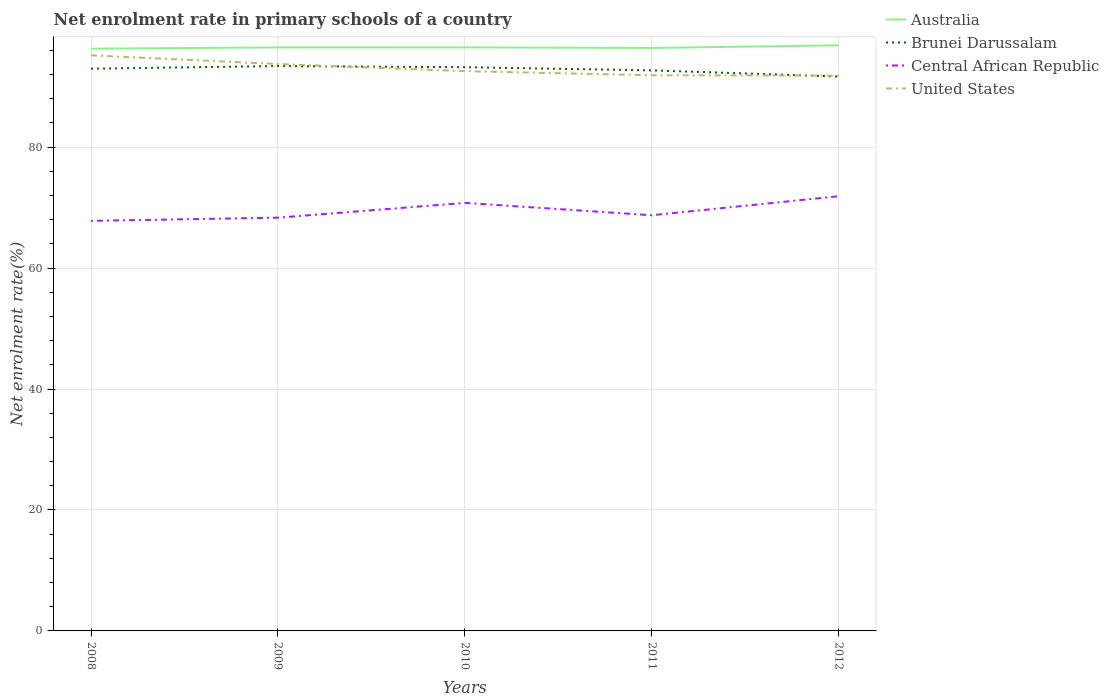How many different coloured lines are there?
Keep it short and to the point. 4. Is the number of lines equal to the number of legend labels?
Your answer should be compact. Yes. Across all years, what is the maximum net enrolment rate in primary schools in Central African Republic?
Keep it short and to the point. 67.8. What is the total net enrolment rate in primary schools in Central African Republic in the graph?
Offer a terse response. 2.05. What is the difference between the highest and the second highest net enrolment rate in primary schools in Australia?
Keep it short and to the point. 0.55. How many lines are there?
Make the answer very short. 4. What is the difference between two consecutive major ticks on the Y-axis?
Keep it short and to the point. 20. Does the graph contain grids?
Offer a very short reply. Yes. Where does the legend appear in the graph?
Your answer should be very brief. Top right. How are the legend labels stacked?
Provide a short and direct response. Vertical. What is the title of the graph?
Ensure brevity in your answer.  Net enrolment rate in primary schools of a country. Does "Low income" appear as one of the legend labels in the graph?
Keep it short and to the point. No. What is the label or title of the X-axis?
Keep it short and to the point. Years. What is the label or title of the Y-axis?
Provide a short and direct response. Net enrolment rate(%). What is the Net enrolment rate(%) in Australia in 2008?
Give a very brief answer. 96.27. What is the Net enrolment rate(%) of Brunei Darussalam in 2008?
Ensure brevity in your answer.  92.97. What is the Net enrolment rate(%) in Central African Republic in 2008?
Provide a succinct answer. 67.8. What is the Net enrolment rate(%) in United States in 2008?
Keep it short and to the point. 95.17. What is the Net enrolment rate(%) of Australia in 2009?
Make the answer very short. 96.49. What is the Net enrolment rate(%) of Brunei Darussalam in 2009?
Ensure brevity in your answer.  93.4. What is the Net enrolment rate(%) in Central African Republic in 2009?
Provide a short and direct response. 68.33. What is the Net enrolment rate(%) in United States in 2009?
Ensure brevity in your answer.  93.73. What is the Net enrolment rate(%) in Australia in 2010?
Your response must be concise. 96.49. What is the Net enrolment rate(%) in Brunei Darussalam in 2010?
Your answer should be compact. 93.21. What is the Net enrolment rate(%) of Central African Republic in 2010?
Your answer should be compact. 70.77. What is the Net enrolment rate(%) in United States in 2010?
Provide a short and direct response. 92.56. What is the Net enrolment rate(%) in Australia in 2011?
Give a very brief answer. 96.4. What is the Net enrolment rate(%) of Brunei Darussalam in 2011?
Provide a succinct answer. 92.69. What is the Net enrolment rate(%) in Central African Republic in 2011?
Offer a terse response. 68.73. What is the Net enrolment rate(%) of United States in 2011?
Provide a short and direct response. 91.88. What is the Net enrolment rate(%) of Australia in 2012?
Keep it short and to the point. 96.82. What is the Net enrolment rate(%) of Brunei Darussalam in 2012?
Your answer should be very brief. 91.66. What is the Net enrolment rate(%) of Central African Republic in 2012?
Ensure brevity in your answer.  71.88. What is the Net enrolment rate(%) of United States in 2012?
Keep it short and to the point. 91.82. Across all years, what is the maximum Net enrolment rate(%) in Australia?
Give a very brief answer. 96.82. Across all years, what is the maximum Net enrolment rate(%) of Brunei Darussalam?
Provide a short and direct response. 93.4. Across all years, what is the maximum Net enrolment rate(%) in Central African Republic?
Your response must be concise. 71.88. Across all years, what is the maximum Net enrolment rate(%) of United States?
Your response must be concise. 95.17. Across all years, what is the minimum Net enrolment rate(%) in Australia?
Keep it short and to the point. 96.27. Across all years, what is the minimum Net enrolment rate(%) in Brunei Darussalam?
Your answer should be very brief. 91.66. Across all years, what is the minimum Net enrolment rate(%) in Central African Republic?
Your answer should be very brief. 67.8. Across all years, what is the minimum Net enrolment rate(%) of United States?
Ensure brevity in your answer.  91.82. What is the total Net enrolment rate(%) of Australia in the graph?
Your answer should be compact. 482.46. What is the total Net enrolment rate(%) of Brunei Darussalam in the graph?
Make the answer very short. 463.92. What is the total Net enrolment rate(%) in Central African Republic in the graph?
Ensure brevity in your answer.  347.51. What is the total Net enrolment rate(%) in United States in the graph?
Provide a short and direct response. 465.16. What is the difference between the Net enrolment rate(%) of Australia in 2008 and that in 2009?
Your answer should be very brief. -0.21. What is the difference between the Net enrolment rate(%) in Brunei Darussalam in 2008 and that in 2009?
Your answer should be very brief. -0.43. What is the difference between the Net enrolment rate(%) of Central African Republic in 2008 and that in 2009?
Offer a very short reply. -0.53. What is the difference between the Net enrolment rate(%) in United States in 2008 and that in 2009?
Provide a short and direct response. 1.44. What is the difference between the Net enrolment rate(%) of Australia in 2008 and that in 2010?
Give a very brief answer. -0.22. What is the difference between the Net enrolment rate(%) in Brunei Darussalam in 2008 and that in 2010?
Provide a short and direct response. -0.24. What is the difference between the Net enrolment rate(%) of Central African Republic in 2008 and that in 2010?
Keep it short and to the point. -2.97. What is the difference between the Net enrolment rate(%) in United States in 2008 and that in 2010?
Give a very brief answer. 2.61. What is the difference between the Net enrolment rate(%) in Australia in 2008 and that in 2011?
Provide a short and direct response. -0.12. What is the difference between the Net enrolment rate(%) in Brunei Darussalam in 2008 and that in 2011?
Your response must be concise. 0.28. What is the difference between the Net enrolment rate(%) of Central African Republic in 2008 and that in 2011?
Offer a terse response. -0.93. What is the difference between the Net enrolment rate(%) in United States in 2008 and that in 2011?
Your response must be concise. 3.3. What is the difference between the Net enrolment rate(%) of Australia in 2008 and that in 2012?
Ensure brevity in your answer.  -0.55. What is the difference between the Net enrolment rate(%) of Brunei Darussalam in 2008 and that in 2012?
Provide a short and direct response. 1.31. What is the difference between the Net enrolment rate(%) of Central African Republic in 2008 and that in 2012?
Give a very brief answer. -4.07. What is the difference between the Net enrolment rate(%) of United States in 2008 and that in 2012?
Give a very brief answer. 3.35. What is the difference between the Net enrolment rate(%) of Australia in 2009 and that in 2010?
Your answer should be compact. -0.01. What is the difference between the Net enrolment rate(%) in Brunei Darussalam in 2009 and that in 2010?
Your response must be concise. 0.19. What is the difference between the Net enrolment rate(%) of Central African Republic in 2009 and that in 2010?
Your response must be concise. -2.45. What is the difference between the Net enrolment rate(%) in United States in 2009 and that in 2010?
Provide a short and direct response. 1.17. What is the difference between the Net enrolment rate(%) of Australia in 2009 and that in 2011?
Your response must be concise. 0.09. What is the difference between the Net enrolment rate(%) in Brunei Darussalam in 2009 and that in 2011?
Make the answer very short. 0.71. What is the difference between the Net enrolment rate(%) of Central African Republic in 2009 and that in 2011?
Your answer should be very brief. -0.4. What is the difference between the Net enrolment rate(%) of United States in 2009 and that in 2011?
Give a very brief answer. 1.86. What is the difference between the Net enrolment rate(%) of Australia in 2009 and that in 2012?
Offer a very short reply. -0.34. What is the difference between the Net enrolment rate(%) of Brunei Darussalam in 2009 and that in 2012?
Make the answer very short. 1.74. What is the difference between the Net enrolment rate(%) in Central African Republic in 2009 and that in 2012?
Give a very brief answer. -3.55. What is the difference between the Net enrolment rate(%) in United States in 2009 and that in 2012?
Keep it short and to the point. 1.91. What is the difference between the Net enrolment rate(%) in Australia in 2010 and that in 2011?
Ensure brevity in your answer.  0.1. What is the difference between the Net enrolment rate(%) of Brunei Darussalam in 2010 and that in 2011?
Offer a terse response. 0.52. What is the difference between the Net enrolment rate(%) in Central African Republic in 2010 and that in 2011?
Ensure brevity in your answer.  2.05. What is the difference between the Net enrolment rate(%) in United States in 2010 and that in 2011?
Offer a terse response. 0.68. What is the difference between the Net enrolment rate(%) of Australia in 2010 and that in 2012?
Keep it short and to the point. -0.33. What is the difference between the Net enrolment rate(%) of Brunei Darussalam in 2010 and that in 2012?
Offer a very short reply. 1.55. What is the difference between the Net enrolment rate(%) of Central African Republic in 2010 and that in 2012?
Your answer should be very brief. -1.1. What is the difference between the Net enrolment rate(%) in United States in 2010 and that in 2012?
Give a very brief answer. 0.73. What is the difference between the Net enrolment rate(%) in Australia in 2011 and that in 2012?
Offer a very short reply. -0.43. What is the difference between the Net enrolment rate(%) of Brunei Darussalam in 2011 and that in 2012?
Offer a terse response. 1.03. What is the difference between the Net enrolment rate(%) in Central African Republic in 2011 and that in 2012?
Ensure brevity in your answer.  -3.15. What is the difference between the Net enrolment rate(%) of United States in 2011 and that in 2012?
Your response must be concise. 0.05. What is the difference between the Net enrolment rate(%) in Australia in 2008 and the Net enrolment rate(%) in Brunei Darussalam in 2009?
Your answer should be very brief. 2.87. What is the difference between the Net enrolment rate(%) of Australia in 2008 and the Net enrolment rate(%) of Central African Republic in 2009?
Offer a terse response. 27.94. What is the difference between the Net enrolment rate(%) of Australia in 2008 and the Net enrolment rate(%) of United States in 2009?
Keep it short and to the point. 2.54. What is the difference between the Net enrolment rate(%) of Brunei Darussalam in 2008 and the Net enrolment rate(%) of Central African Republic in 2009?
Ensure brevity in your answer.  24.64. What is the difference between the Net enrolment rate(%) in Brunei Darussalam in 2008 and the Net enrolment rate(%) in United States in 2009?
Ensure brevity in your answer.  -0.77. What is the difference between the Net enrolment rate(%) in Central African Republic in 2008 and the Net enrolment rate(%) in United States in 2009?
Make the answer very short. -25.93. What is the difference between the Net enrolment rate(%) in Australia in 2008 and the Net enrolment rate(%) in Brunei Darussalam in 2010?
Ensure brevity in your answer.  3.06. What is the difference between the Net enrolment rate(%) of Australia in 2008 and the Net enrolment rate(%) of Central African Republic in 2010?
Keep it short and to the point. 25.5. What is the difference between the Net enrolment rate(%) in Australia in 2008 and the Net enrolment rate(%) in United States in 2010?
Make the answer very short. 3.71. What is the difference between the Net enrolment rate(%) in Brunei Darussalam in 2008 and the Net enrolment rate(%) in Central African Republic in 2010?
Make the answer very short. 22.19. What is the difference between the Net enrolment rate(%) in Brunei Darussalam in 2008 and the Net enrolment rate(%) in United States in 2010?
Offer a terse response. 0.41. What is the difference between the Net enrolment rate(%) of Central African Republic in 2008 and the Net enrolment rate(%) of United States in 2010?
Provide a short and direct response. -24.76. What is the difference between the Net enrolment rate(%) of Australia in 2008 and the Net enrolment rate(%) of Brunei Darussalam in 2011?
Provide a succinct answer. 3.58. What is the difference between the Net enrolment rate(%) in Australia in 2008 and the Net enrolment rate(%) in Central African Republic in 2011?
Provide a succinct answer. 27.54. What is the difference between the Net enrolment rate(%) of Australia in 2008 and the Net enrolment rate(%) of United States in 2011?
Provide a succinct answer. 4.4. What is the difference between the Net enrolment rate(%) in Brunei Darussalam in 2008 and the Net enrolment rate(%) in Central African Republic in 2011?
Your answer should be very brief. 24.24. What is the difference between the Net enrolment rate(%) of Brunei Darussalam in 2008 and the Net enrolment rate(%) of United States in 2011?
Make the answer very short. 1.09. What is the difference between the Net enrolment rate(%) of Central African Republic in 2008 and the Net enrolment rate(%) of United States in 2011?
Make the answer very short. -24.07. What is the difference between the Net enrolment rate(%) of Australia in 2008 and the Net enrolment rate(%) of Brunei Darussalam in 2012?
Keep it short and to the point. 4.61. What is the difference between the Net enrolment rate(%) of Australia in 2008 and the Net enrolment rate(%) of Central African Republic in 2012?
Offer a very short reply. 24.39. What is the difference between the Net enrolment rate(%) of Australia in 2008 and the Net enrolment rate(%) of United States in 2012?
Provide a short and direct response. 4.45. What is the difference between the Net enrolment rate(%) of Brunei Darussalam in 2008 and the Net enrolment rate(%) of Central African Republic in 2012?
Provide a succinct answer. 21.09. What is the difference between the Net enrolment rate(%) in Brunei Darussalam in 2008 and the Net enrolment rate(%) in United States in 2012?
Your answer should be compact. 1.14. What is the difference between the Net enrolment rate(%) in Central African Republic in 2008 and the Net enrolment rate(%) in United States in 2012?
Give a very brief answer. -24.02. What is the difference between the Net enrolment rate(%) of Australia in 2009 and the Net enrolment rate(%) of Brunei Darussalam in 2010?
Ensure brevity in your answer.  3.28. What is the difference between the Net enrolment rate(%) in Australia in 2009 and the Net enrolment rate(%) in Central African Republic in 2010?
Keep it short and to the point. 25.71. What is the difference between the Net enrolment rate(%) of Australia in 2009 and the Net enrolment rate(%) of United States in 2010?
Give a very brief answer. 3.93. What is the difference between the Net enrolment rate(%) in Brunei Darussalam in 2009 and the Net enrolment rate(%) in Central African Republic in 2010?
Keep it short and to the point. 22.62. What is the difference between the Net enrolment rate(%) of Brunei Darussalam in 2009 and the Net enrolment rate(%) of United States in 2010?
Your answer should be compact. 0.84. What is the difference between the Net enrolment rate(%) of Central African Republic in 2009 and the Net enrolment rate(%) of United States in 2010?
Ensure brevity in your answer.  -24.23. What is the difference between the Net enrolment rate(%) in Australia in 2009 and the Net enrolment rate(%) in Brunei Darussalam in 2011?
Provide a short and direct response. 3.8. What is the difference between the Net enrolment rate(%) in Australia in 2009 and the Net enrolment rate(%) in Central African Republic in 2011?
Your answer should be very brief. 27.76. What is the difference between the Net enrolment rate(%) of Australia in 2009 and the Net enrolment rate(%) of United States in 2011?
Your answer should be compact. 4.61. What is the difference between the Net enrolment rate(%) of Brunei Darussalam in 2009 and the Net enrolment rate(%) of Central African Republic in 2011?
Keep it short and to the point. 24.67. What is the difference between the Net enrolment rate(%) in Brunei Darussalam in 2009 and the Net enrolment rate(%) in United States in 2011?
Offer a terse response. 1.52. What is the difference between the Net enrolment rate(%) in Central African Republic in 2009 and the Net enrolment rate(%) in United States in 2011?
Provide a succinct answer. -23.55. What is the difference between the Net enrolment rate(%) in Australia in 2009 and the Net enrolment rate(%) in Brunei Darussalam in 2012?
Offer a terse response. 4.82. What is the difference between the Net enrolment rate(%) in Australia in 2009 and the Net enrolment rate(%) in Central African Republic in 2012?
Provide a succinct answer. 24.61. What is the difference between the Net enrolment rate(%) of Australia in 2009 and the Net enrolment rate(%) of United States in 2012?
Offer a terse response. 4.66. What is the difference between the Net enrolment rate(%) of Brunei Darussalam in 2009 and the Net enrolment rate(%) of Central African Republic in 2012?
Make the answer very short. 21.52. What is the difference between the Net enrolment rate(%) of Brunei Darussalam in 2009 and the Net enrolment rate(%) of United States in 2012?
Make the answer very short. 1.57. What is the difference between the Net enrolment rate(%) in Central African Republic in 2009 and the Net enrolment rate(%) in United States in 2012?
Give a very brief answer. -23.5. What is the difference between the Net enrolment rate(%) of Australia in 2010 and the Net enrolment rate(%) of Brunei Darussalam in 2011?
Your response must be concise. 3.8. What is the difference between the Net enrolment rate(%) in Australia in 2010 and the Net enrolment rate(%) in Central African Republic in 2011?
Provide a succinct answer. 27.76. What is the difference between the Net enrolment rate(%) in Australia in 2010 and the Net enrolment rate(%) in United States in 2011?
Provide a short and direct response. 4.62. What is the difference between the Net enrolment rate(%) in Brunei Darussalam in 2010 and the Net enrolment rate(%) in Central African Republic in 2011?
Your response must be concise. 24.48. What is the difference between the Net enrolment rate(%) of Brunei Darussalam in 2010 and the Net enrolment rate(%) of United States in 2011?
Your answer should be very brief. 1.33. What is the difference between the Net enrolment rate(%) of Central African Republic in 2010 and the Net enrolment rate(%) of United States in 2011?
Provide a short and direct response. -21.1. What is the difference between the Net enrolment rate(%) of Australia in 2010 and the Net enrolment rate(%) of Brunei Darussalam in 2012?
Your answer should be very brief. 4.83. What is the difference between the Net enrolment rate(%) of Australia in 2010 and the Net enrolment rate(%) of Central African Republic in 2012?
Give a very brief answer. 24.61. What is the difference between the Net enrolment rate(%) in Australia in 2010 and the Net enrolment rate(%) in United States in 2012?
Offer a terse response. 4.67. What is the difference between the Net enrolment rate(%) of Brunei Darussalam in 2010 and the Net enrolment rate(%) of Central African Republic in 2012?
Give a very brief answer. 21.33. What is the difference between the Net enrolment rate(%) in Brunei Darussalam in 2010 and the Net enrolment rate(%) in United States in 2012?
Provide a succinct answer. 1.38. What is the difference between the Net enrolment rate(%) in Central African Republic in 2010 and the Net enrolment rate(%) in United States in 2012?
Offer a very short reply. -21.05. What is the difference between the Net enrolment rate(%) of Australia in 2011 and the Net enrolment rate(%) of Brunei Darussalam in 2012?
Provide a succinct answer. 4.74. What is the difference between the Net enrolment rate(%) of Australia in 2011 and the Net enrolment rate(%) of Central African Republic in 2012?
Offer a very short reply. 24.52. What is the difference between the Net enrolment rate(%) in Australia in 2011 and the Net enrolment rate(%) in United States in 2012?
Make the answer very short. 4.57. What is the difference between the Net enrolment rate(%) of Brunei Darussalam in 2011 and the Net enrolment rate(%) of Central African Republic in 2012?
Provide a succinct answer. 20.81. What is the difference between the Net enrolment rate(%) in Brunei Darussalam in 2011 and the Net enrolment rate(%) in United States in 2012?
Your answer should be compact. 0.86. What is the difference between the Net enrolment rate(%) in Central African Republic in 2011 and the Net enrolment rate(%) in United States in 2012?
Your answer should be compact. -23.1. What is the average Net enrolment rate(%) in Australia per year?
Offer a very short reply. 96.49. What is the average Net enrolment rate(%) of Brunei Darussalam per year?
Make the answer very short. 92.78. What is the average Net enrolment rate(%) in Central African Republic per year?
Offer a terse response. 69.5. What is the average Net enrolment rate(%) of United States per year?
Make the answer very short. 93.03. In the year 2008, what is the difference between the Net enrolment rate(%) in Australia and Net enrolment rate(%) in Brunei Darussalam?
Keep it short and to the point. 3.3. In the year 2008, what is the difference between the Net enrolment rate(%) in Australia and Net enrolment rate(%) in Central African Republic?
Ensure brevity in your answer.  28.47. In the year 2008, what is the difference between the Net enrolment rate(%) in Australia and Net enrolment rate(%) in United States?
Provide a succinct answer. 1.1. In the year 2008, what is the difference between the Net enrolment rate(%) of Brunei Darussalam and Net enrolment rate(%) of Central African Republic?
Give a very brief answer. 25.16. In the year 2008, what is the difference between the Net enrolment rate(%) in Brunei Darussalam and Net enrolment rate(%) in United States?
Provide a short and direct response. -2.21. In the year 2008, what is the difference between the Net enrolment rate(%) of Central African Republic and Net enrolment rate(%) of United States?
Make the answer very short. -27.37. In the year 2009, what is the difference between the Net enrolment rate(%) of Australia and Net enrolment rate(%) of Brunei Darussalam?
Keep it short and to the point. 3.09. In the year 2009, what is the difference between the Net enrolment rate(%) in Australia and Net enrolment rate(%) in Central African Republic?
Your response must be concise. 28.16. In the year 2009, what is the difference between the Net enrolment rate(%) of Australia and Net enrolment rate(%) of United States?
Your response must be concise. 2.75. In the year 2009, what is the difference between the Net enrolment rate(%) of Brunei Darussalam and Net enrolment rate(%) of Central African Republic?
Ensure brevity in your answer.  25.07. In the year 2009, what is the difference between the Net enrolment rate(%) in Brunei Darussalam and Net enrolment rate(%) in United States?
Keep it short and to the point. -0.33. In the year 2009, what is the difference between the Net enrolment rate(%) of Central African Republic and Net enrolment rate(%) of United States?
Give a very brief answer. -25.4. In the year 2010, what is the difference between the Net enrolment rate(%) in Australia and Net enrolment rate(%) in Brunei Darussalam?
Offer a terse response. 3.28. In the year 2010, what is the difference between the Net enrolment rate(%) in Australia and Net enrolment rate(%) in Central African Republic?
Offer a very short reply. 25.72. In the year 2010, what is the difference between the Net enrolment rate(%) in Australia and Net enrolment rate(%) in United States?
Your answer should be very brief. 3.93. In the year 2010, what is the difference between the Net enrolment rate(%) of Brunei Darussalam and Net enrolment rate(%) of Central African Republic?
Offer a terse response. 22.43. In the year 2010, what is the difference between the Net enrolment rate(%) in Brunei Darussalam and Net enrolment rate(%) in United States?
Keep it short and to the point. 0.65. In the year 2010, what is the difference between the Net enrolment rate(%) of Central African Republic and Net enrolment rate(%) of United States?
Give a very brief answer. -21.78. In the year 2011, what is the difference between the Net enrolment rate(%) of Australia and Net enrolment rate(%) of Brunei Darussalam?
Your answer should be compact. 3.71. In the year 2011, what is the difference between the Net enrolment rate(%) in Australia and Net enrolment rate(%) in Central African Republic?
Your response must be concise. 27.67. In the year 2011, what is the difference between the Net enrolment rate(%) of Australia and Net enrolment rate(%) of United States?
Ensure brevity in your answer.  4.52. In the year 2011, what is the difference between the Net enrolment rate(%) in Brunei Darussalam and Net enrolment rate(%) in Central African Republic?
Provide a short and direct response. 23.96. In the year 2011, what is the difference between the Net enrolment rate(%) in Brunei Darussalam and Net enrolment rate(%) in United States?
Your response must be concise. 0.81. In the year 2011, what is the difference between the Net enrolment rate(%) in Central African Republic and Net enrolment rate(%) in United States?
Ensure brevity in your answer.  -23.15. In the year 2012, what is the difference between the Net enrolment rate(%) of Australia and Net enrolment rate(%) of Brunei Darussalam?
Offer a very short reply. 5.16. In the year 2012, what is the difference between the Net enrolment rate(%) in Australia and Net enrolment rate(%) in Central African Republic?
Your response must be concise. 24.95. In the year 2012, what is the difference between the Net enrolment rate(%) in Australia and Net enrolment rate(%) in United States?
Your response must be concise. 5. In the year 2012, what is the difference between the Net enrolment rate(%) of Brunei Darussalam and Net enrolment rate(%) of Central African Republic?
Provide a succinct answer. 19.78. In the year 2012, what is the difference between the Net enrolment rate(%) of Brunei Darussalam and Net enrolment rate(%) of United States?
Make the answer very short. -0.16. In the year 2012, what is the difference between the Net enrolment rate(%) of Central African Republic and Net enrolment rate(%) of United States?
Give a very brief answer. -19.95. What is the ratio of the Net enrolment rate(%) in Brunei Darussalam in 2008 to that in 2009?
Ensure brevity in your answer.  1. What is the ratio of the Net enrolment rate(%) of Central African Republic in 2008 to that in 2009?
Your answer should be very brief. 0.99. What is the ratio of the Net enrolment rate(%) in United States in 2008 to that in 2009?
Your answer should be very brief. 1.02. What is the ratio of the Net enrolment rate(%) in Australia in 2008 to that in 2010?
Your answer should be compact. 1. What is the ratio of the Net enrolment rate(%) in Brunei Darussalam in 2008 to that in 2010?
Offer a very short reply. 1. What is the ratio of the Net enrolment rate(%) of Central African Republic in 2008 to that in 2010?
Ensure brevity in your answer.  0.96. What is the ratio of the Net enrolment rate(%) in United States in 2008 to that in 2010?
Ensure brevity in your answer.  1.03. What is the ratio of the Net enrolment rate(%) in Australia in 2008 to that in 2011?
Ensure brevity in your answer.  1. What is the ratio of the Net enrolment rate(%) of Brunei Darussalam in 2008 to that in 2011?
Give a very brief answer. 1. What is the ratio of the Net enrolment rate(%) in Central African Republic in 2008 to that in 2011?
Your answer should be compact. 0.99. What is the ratio of the Net enrolment rate(%) of United States in 2008 to that in 2011?
Offer a very short reply. 1.04. What is the ratio of the Net enrolment rate(%) of Brunei Darussalam in 2008 to that in 2012?
Offer a very short reply. 1.01. What is the ratio of the Net enrolment rate(%) of Central African Republic in 2008 to that in 2012?
Give a very brief answer. 0.94. What is the ratio of the Net enrolment rate(%) of United States in 2008 to that in 2012?
Keep it short and to the point. 1.04. What is the ratio of the Net enrolment rate(%) in Brunei Darussalam in 2009 to that in 2010?
Ensure brevity in your answer.  1. What is the ratio of the Net enrolment rate(%) in Central African Republic in 2009 to that in 2010?
Offer a terse response. 0.97. What is the ratio of the Net enrolment rate(%) in United States in 2009 to that in 2010?
Your response must be concise. 1.01. What is the ratio of the Net enrolment rate(%) of Brunei Darussalam in 2009 to that in 2011?
Offer a terse response. 1.01. What is the ratio of the Net enrolment rate(%) of United States in 2009 to that in 2011?
Offer a very short reply. 1.02. What is the ratio of the Net enrolment rate(%) of Australia in 2009 to that in 2012?
Your answer should be compact. 1. What is the ratio of the Net enrolment rate(%) in Central African Republic in 2009 to that in 2012?
Your answer should be compact. 0.95. What is the ratio of the Net enrolment rate(%) in United States in 2009 to that in 2012?
Provide a short and direct response. 1.02. What is the ratio of the Net enrolment rate(%) of Australia in 2010 to that in 2011?
Keep it short and to the point. 1. What is the ratio of the Net enrolment rate(%) of Brunei Darussalam in 2010 to that in 2011?
Your answer should be very brief. 1.01. What is the ratio of the Net enrolment rate(%) in Central African Republic in 2010 to that in 2011?
Offer a terse response. 1.03. What is the ratio of the Net enrolment rate(%) of United States in 2010 to that in 2011?
Your answer should be compact. 1.01. What is the ratio of the Net enrolment rate(%) in Brunei Darussalam in 2010 to that in 2012?
Provide a short and direct response. 1.02. What is the ratio of the Net enrolment rate(%) of Central African Republic in 2010 to that in 2012?
Your answer should be very brief. 0.98. What is the ratio of the Net enrolment rate(%) in United States in 2010 to that in 2012?
Offer a very short reply. 1.01. What is the ratio of the Net enrolment rate(%) in Australia in 2011 to that in 2012?
Ensure brevity in your answer.  1. What is the ratio of the Net enrolment rate(%) of Brunei Darussalam in 2011 to that in 2012?
Offer a very short reply. 1.01. What is the ratio of the Net enrolment rate(%) of Central African Republic in 2011 to that in 2012?
Ensure brevity in your answer.  0.96. What is the difference between the highest and the second highest Net enrolment rate(%) of Australia?
Make the answer very short. 0.33. What is the difference between the highest and the second highest Net enrolment rate(%) of Brunei Darussalam?
Provide a short and direct response. 0.19. What is the difference between the highest and the second highest Net enrolment rate(%) in Central African Republic?
Make the answer very short. 1.1. What is the difference between the highest and the second highest Net enrolment rate(%) of United States?
Your answer should be very brief. 1.44. What is the difference between the highest and the lowest Net enrolment rate(%) of Australia?
Keep it short and to the point. 0.55. What is the difference between the highest and the lowest Net enrolment rate(%) in Brunei Darussalam?
Keep it short and to the point. 1.74. What is the difference between the highest and the lowest Net enrolment rate(%) of Central African Republic?
Your answer should be very brief. 4.07. What is the difference between the highest and the lowest Net enrolment rate(%) in United States?
Give a very brief answer. 3.35. 